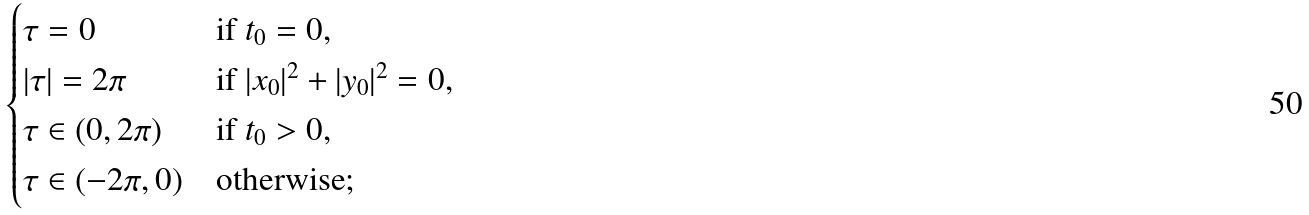<formula> <loc_0><loc_0><loc_500><loc_500>\begin{cases} \tau = 0 & \text {if } t _ { 0 } = 0 , \\ | \tau | = 2 \pi & \text {if } | x _ { 0 } | ^ { 2 } + | y _ { 0 } | ^ { 2 } = 0 , \\ \tau \in { ( 0 , 2 \pi ) } & \text {if } t _ { 0 } > 0 , \\ \tau \in { ( - 2 \pi , 0 ) } & \text {otherwise} ; \end{cases}</formula> 